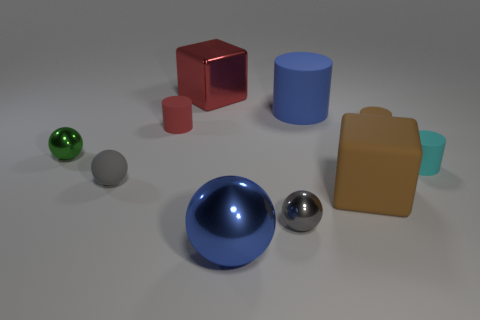Subtract all red spheres. Subtract all gray blocks. How many spheres are left? 4 Subtract all cylinders. How many objects are left? 6 Subtract 1 red cylinders. How many objects are left? 9 Subtract all gray matte balls. Subtract all metal balls. How many objects are left? 6 Add 7 small green objects. How many small green objects are left? 8 Add 1 gray metal things. How many gray metal things exist? 2 